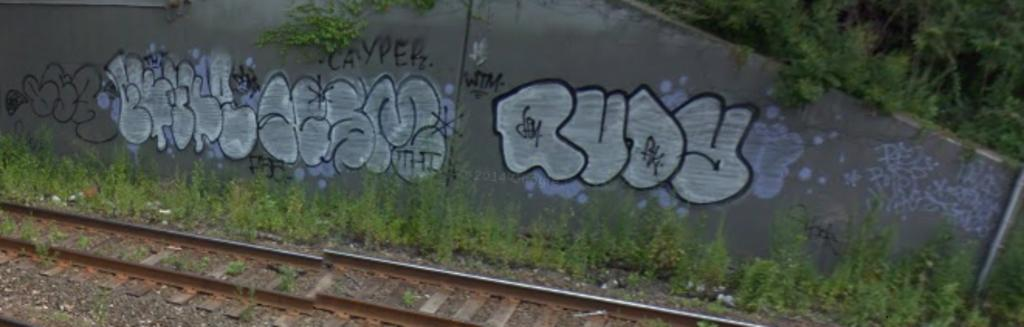<image>
Summarize the visual content of the image. a rudy sign on the side of a wall outside 